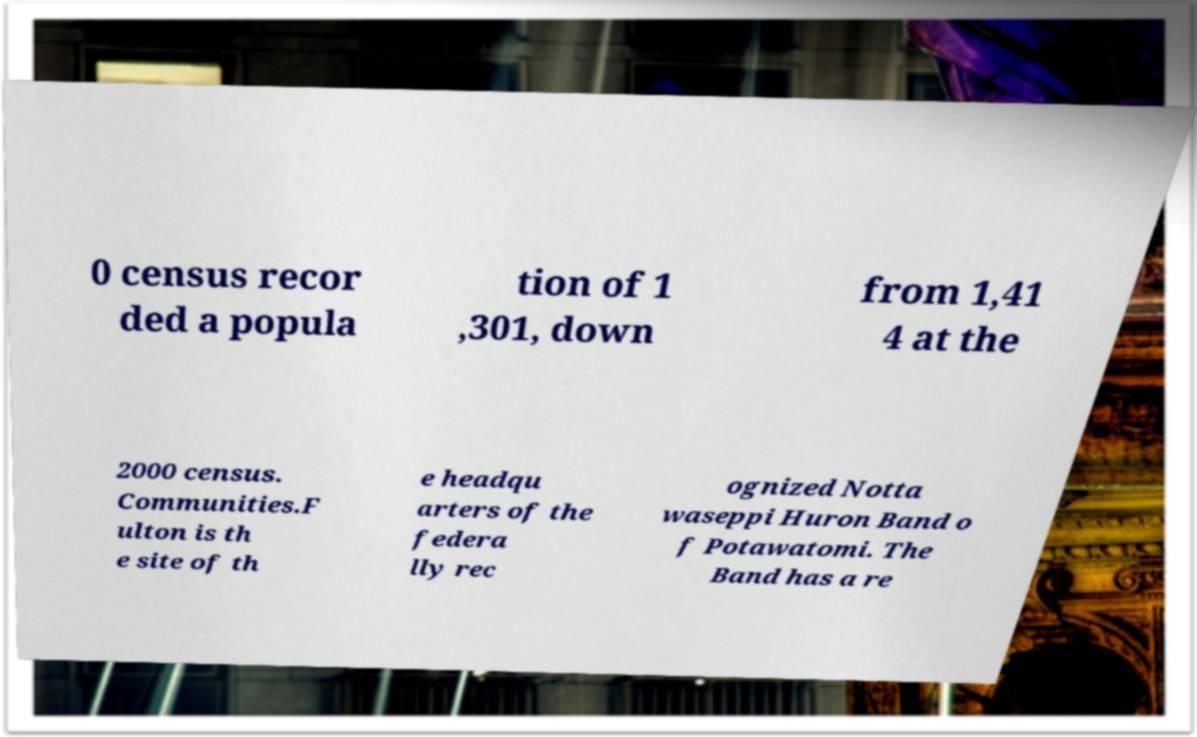Could you assist in decoding the text presented in this image and type it out clearly? 0 census recor ded a popula tion of 1 ,301, down from 1,41 4 at the 2000 census. Communities.F ulton is th e site of th e headqu arters of the federa lly rec ognized Notta waseppi Huron Band o f Potawatomi. The Band has a re 